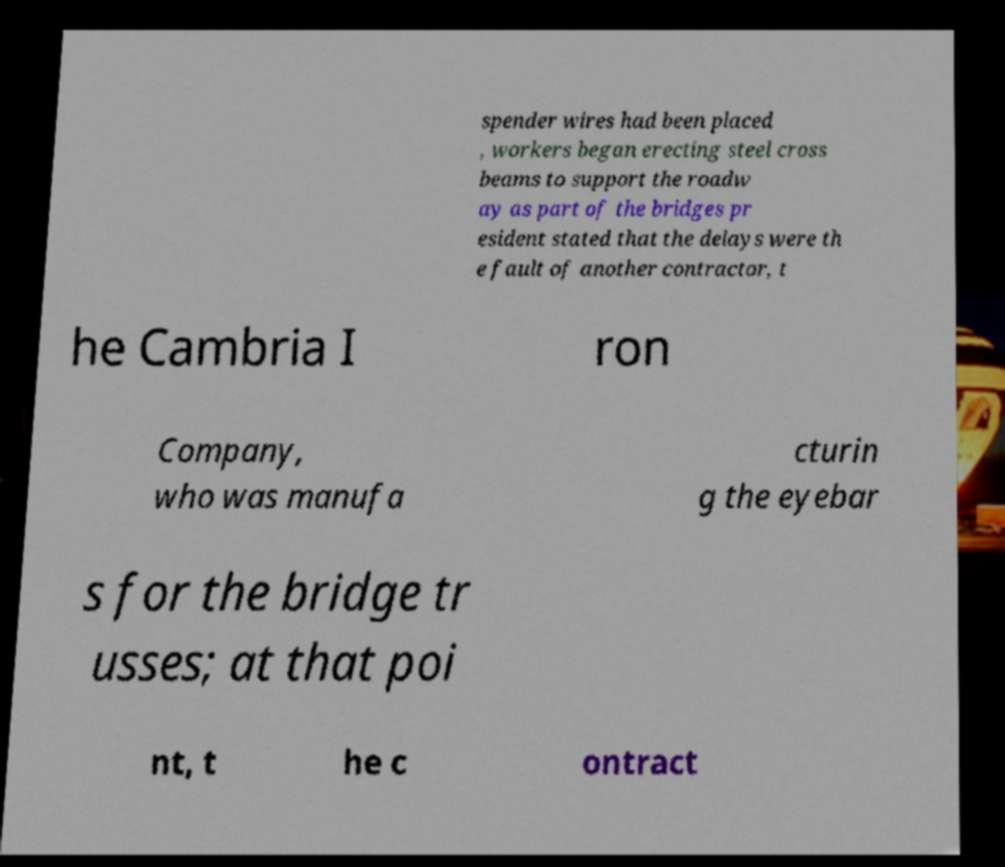For documentation purposes, I need the text within this image transcribed. Could you provide that? spender wires had been placed , workers began erecting steel cross beams to support the roadw ay as part of the bridges pr esident stated that the delays were th e fault of another contractor, t he Cambria I ron Company, who was manufa cturin g the eyebar s for the bridge tr usses; at that poi nt, t he c ontract 